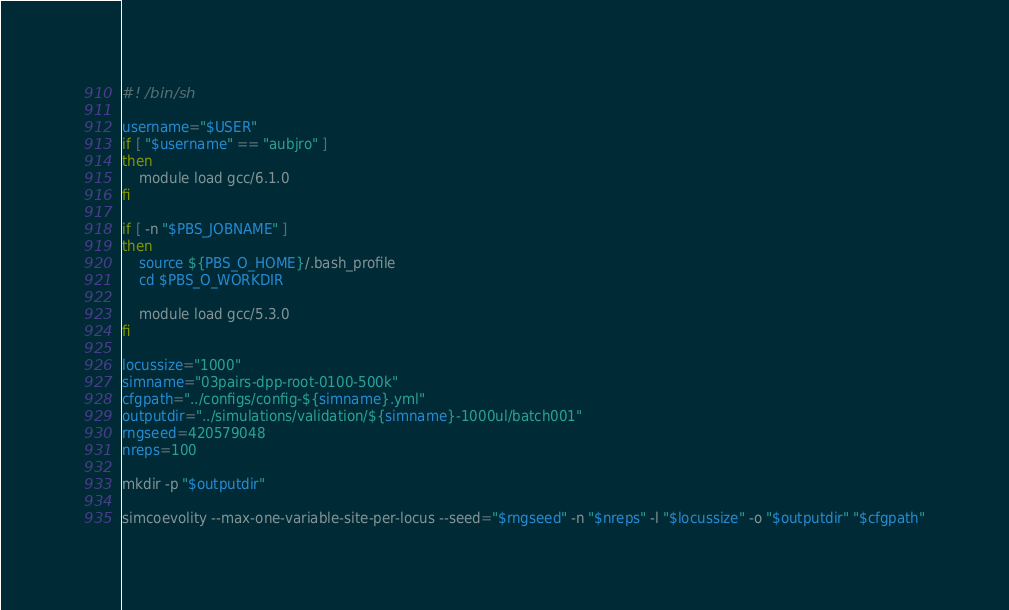<code> <loc_0><loc_0><loc_500><loc_500><_Bash_>#! /bin/sh

username="$USER"
if [ "$username" == "aubjro" ]
then
    module load gcc/6.1.0
fi

if [ -n "$PBS_JOBNAME" ]
then
    source ${PBS_O_HOME}/.bash_profile
    cd $PBS_O_WORKDIR

    module load gcc/5.3.0
fi

locussize="1000"
simname="03pairs-dpp-root-0100-500k"
cfgpath="../configs/config-${simname}.yml"
outputdir="../simulations/validation/${simname}-1000ul/batch001"
rngseed=420579048
nreps=100

mkdir -p "$outputdir"

simcoevolity --max-one-variable-site-per-locus --seed="$rngseed" -n "$nreps" -l "$locussize" -o "$outputdir" "$cfgpath"
</code> 